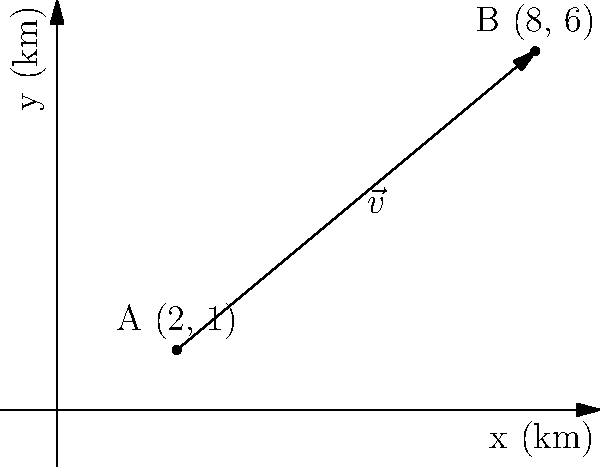As an ecotourism guide, you need to calculate the distance between two eco-lodges in Odisha. Lodge A is located at coordinates (2 km, 1 km) and Lodge B is at (8 km, 6 km) relative to a local landmark. Using vector components, determine the distance between these two lodges. To calculate the distance between the two eco-lodges, we can use the vector between them and find its magnitude. Let's approach this step-by-step:

1) First, we need to find the vector $\vec{v}$ from Lodge A to Lodge B:
   $\vec{v} = B - A = (8,6) - (2,1) = (6,5)$

2) This vector has components $v_x = 6$ km and $v_y = 5$ km.

3) To find the distance, we need to calculate the magnitude of this vector. We can use the Pythagorean theorem:

   $|\vec{v}| = \sqrt{v_x^2 + v_y^2}$

4) Substituting our values:
   $|\vec{v}| = \sqrt{6^2 + 5^2} = \sqrt{36 + 25} = \sqrt{61}$

5) Simplifying:
   $|\vec{v}| = \sqrt{61} \approx 7.81$ km

Therefore, the distance between the two eco-lodges is approximately 7.81 km.
Answer: $\sqrt{61}$ km or approximately 7.81 km 